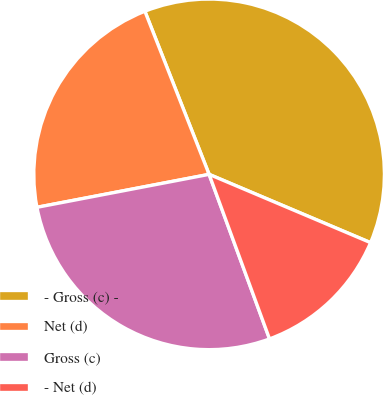Convert chart. <chart><loc_0><loc_0><loc_500><loc_500><pie_chart><fcel>- Gross (c) -<fcel>Net (d)<fcel>Gross (c)<fcel>- Net (d)<nl><fcel>37.34%<fcel>22.04%<fcel>27.59%<fcel>13.03%<nl></chart> 